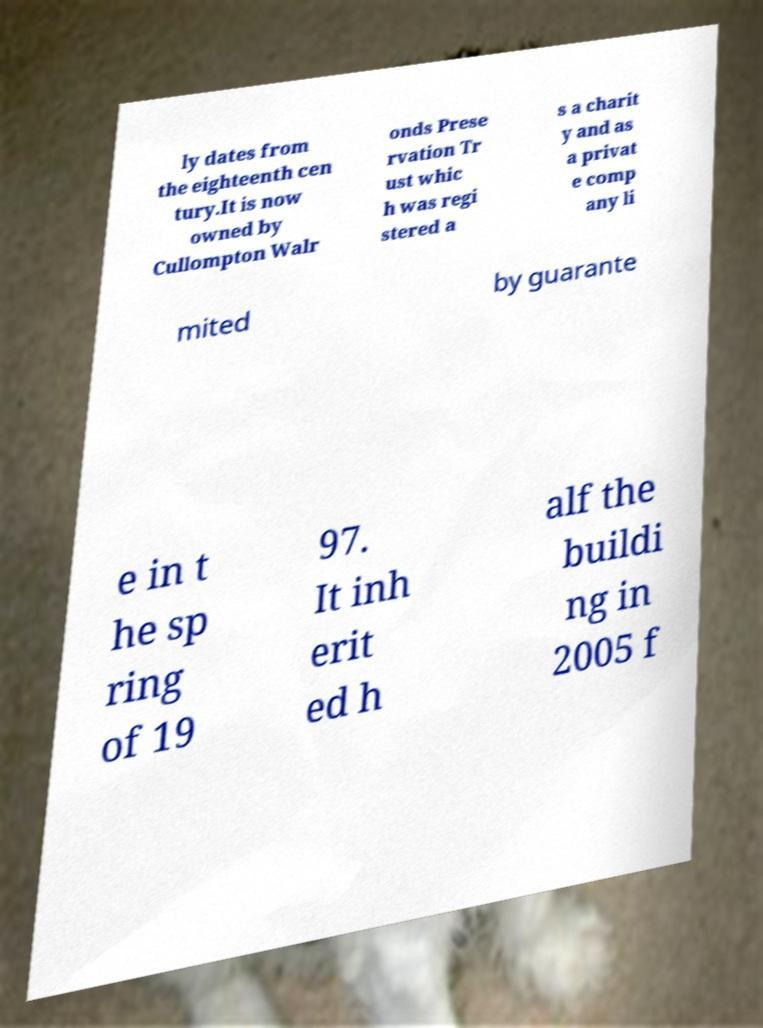Please read and relay the text visible in this image. What does it say? ly dates from the eighteenth cen tury.It is now owned by Cullompton Walr onds Prese rvation Tr ust whic h was regi stered a s a charit y and as a privat e comp any li mited by guarante e in t he sp ring of 19 97. It inh erit ed h alf the buildi ng in 2005 f 